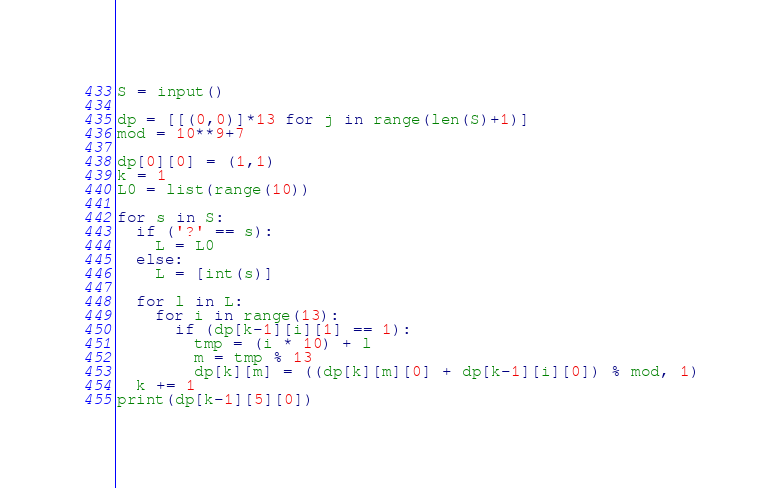<code> <loc_0><loc_0><loc_500><loc_500><_Python_>S = input()
 
dp = [[(0,0)]*13 for j in range(len(S)+1)]
mod = 10**9+7
 
dp[0][0] = (1,1)
k = 1
L0 = list(range(10))

for s in S:
  if ('?' == s):
    L = L0
  else:
    L = [int(s)]
 
  for l in L:
    for i in range(13):
      if (dp[k-1][i][1] == 1):
        tmp = (i * 10) + l
        m = tmp % 13
        dp[k][m] = ((dp[k][m][0] + dp[k-1][i][0]) % mod, 1)
  k += 1
print(dp[k-1][5][0])
</code> 